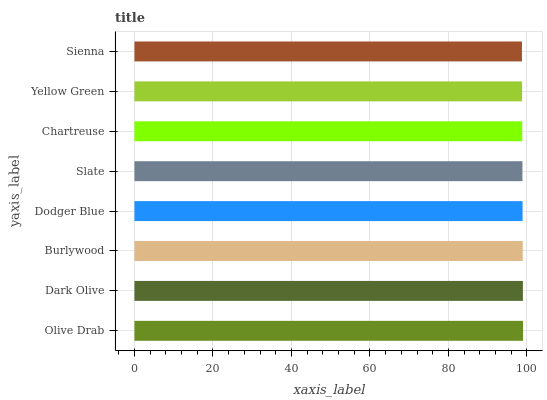Is Sienna the minimum?
Answer yes or no. Yes. Is Olive Drab the maximum?
Answer yes or no. Yes. Is Dark Olive the minimum?
Answer yes or no. No. Is Dark Olive the maximum?
Answer yes or no. No. Is Olive Drab greater than Dark Olive?
Answer yes or no. Yes. Is Dark Olive less than Olive Drab?
Answer yes or no. Yes. Is Dark Olive greater than Olive Drab?
Answer yes or no. No. Is Olive Drab less than Dark Olive?
Answer yes or no. No. Is Dodger Blue the high median?
Answer yes or no. Yes. Is Slate the low median?
Answer yes or no. Yes. Is Yellow Green the high median?
Answer yes or no. No. Is Sienna the low median?
Answer yes or no. No. 